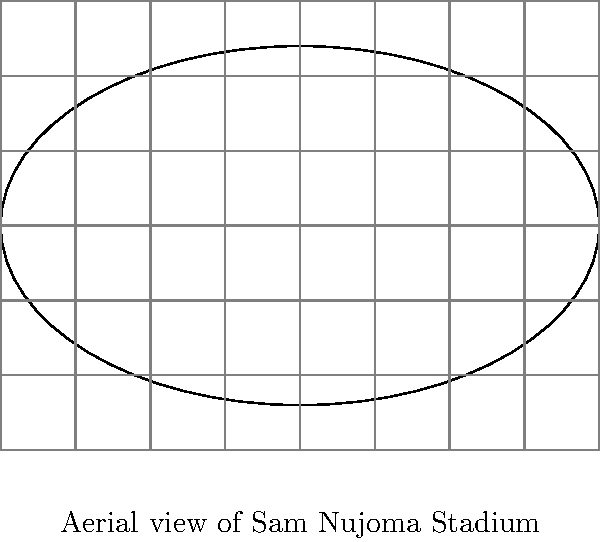In an aerial image of Sam Nujoma Stadium in Windhoek, a grid is superimposed where each cell represents 400 square meters. If the stadium appears to cover approximately 30 cells, what is the estimated crowd size assuming an average of 4 people per square meter in densely packed areas? To estimate the crowd size, we'll follow these steps:

1. Calculate the total area covered by the stadium:
   * Each cell represents 400 square meters
   * The stadium covers approximately 30 cells
   * Total area = $30 \times 400 = 12,000$ square meters

2. Determine the number of people per square meter:
   * Given: 4 people per square meter in densely packed areas

3. Calculate the estimated crowd size:
   * Crowd size = Total area × People per square meter
   * Crowd size = $12,000 \times 4 = 48,000$ people

Therefore, the estimated crowd size in the stadium is 48,000 people.

Note: This estimation assumes uniform density throughout the stadium, which may not be entirely accurate in real-world scenarios. Factors such as seating arrangements, standing areas, and restricted zones could affect the actual crowd size.
Answer: 48,000 people 